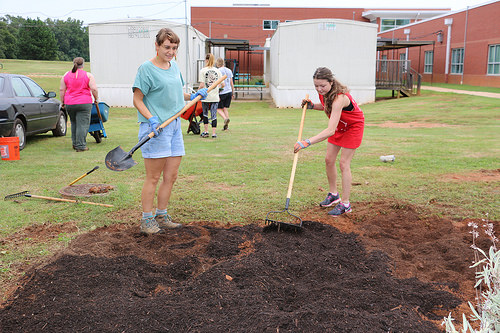<image>
Is there a girl to the left of the woman? Yes. From this viewpoint, the girl is positioned to the left side relative to the woman. 